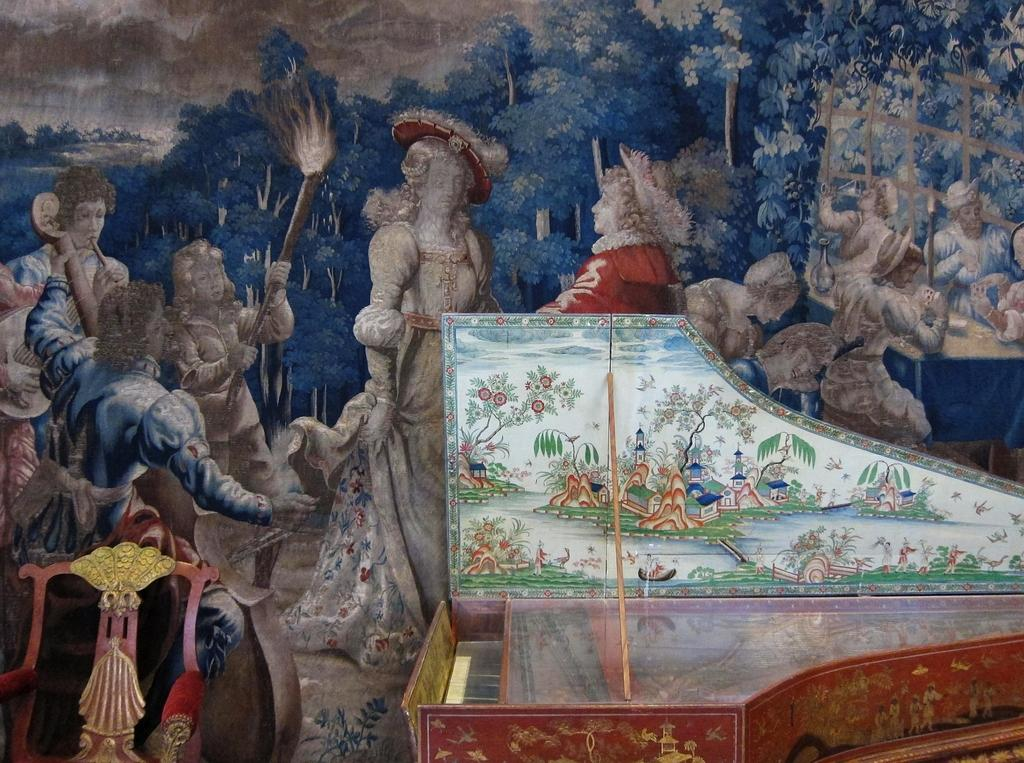What is depicted in the painting in the image? There is a painting of some persons in the image. What object can be seen on the right side of the image? There is a piano on the right side of the image. Where is the chair located in the image? There is a chair at the left bottom of the image. What is the stick used for in the image? The purpose of the stick in the image is not clear, as there is no context provided. Can you see any ocean waves in the image? There is no ocean or waves present in the image. Are there any farm animals visible in the image? There are no farm animals present in the image. 